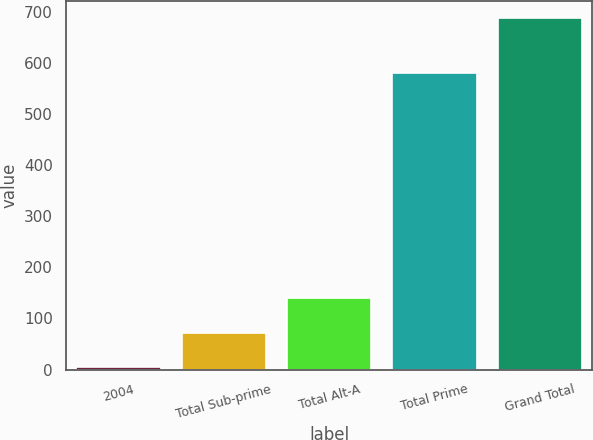<chart> <loc_0><loc_0><loc_500><loc_500><bar_chart><fcel>2004<fcel>Total Sub-prime<fcel>Total Alt-A<fcel>Total Prime<fcel>Grand Total<nl><fcel>4<fcel>72.3<fcel>140.6<fcel>581<fcel>687<nl></chart> 